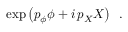Convert formula to latex. <formula><loc_0><loc_0><loc_500><loc_500>\exp \left ( p _ { \phi } \phi + i \, p _ { X } X \right ) \, .</formula> 